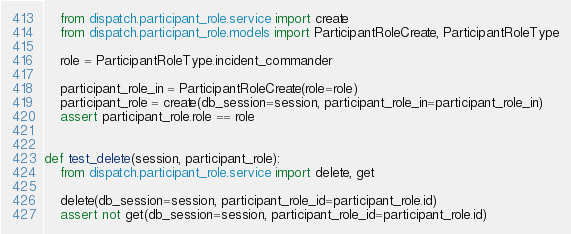<code> <loc_0><loc_0><loc_500><loc_500><_Python_>    from dispatch.participant_role.service import create
    from dispatch.participant_role.models import ParticipantRoleCreate, ParticipantRoleType

    role = ParticipantRoleType.incident_commander

    participant_role_in = ParticipantRoleCreate(role=role)
    participant_role = create(db_session=session, participant_role_in=participant_role_in)
    assert participant_role.role == role


def test_delete(session, participant_role):
    from dispatch.participant_role.service import delete, get

    delete(db_session=session, participant_role_id=participant_role.id)
    assert not get(db_session=session, participant_role_id=participant_role.id)
</code> 